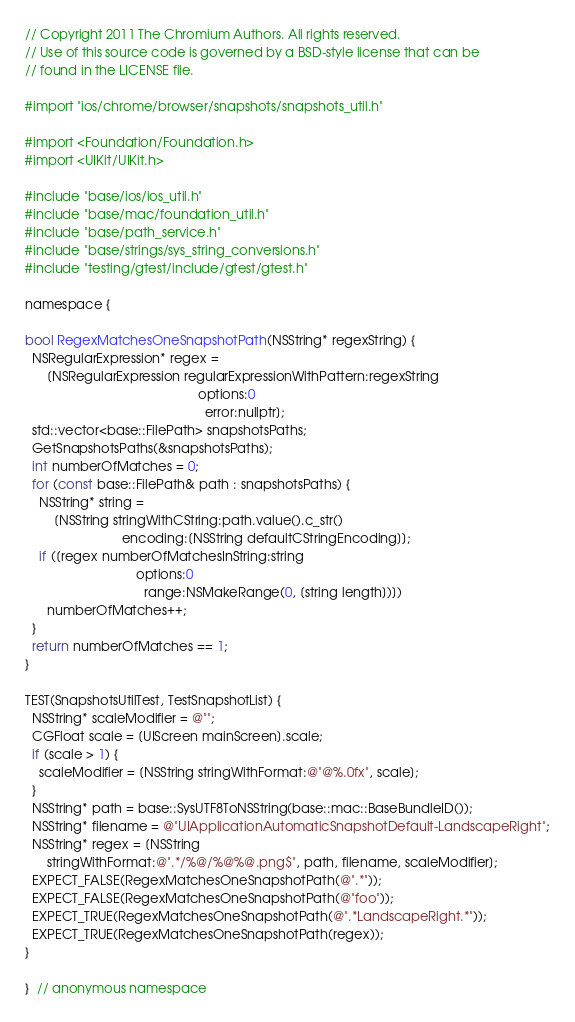Convert code to text. <code><loc_0><loc_0><loc_500><loc_500><_ObjectiveC_>// Copyright 2011 The Chromium Authors. All rights reserved.
// Use of this source code is governed by a BSD-style license that can be
// found in the LICENSE file.

#import "ios/chrome/browser/snapshots/snapshots_util.h"

#import <Foundation/Foundation.h>
#import <UIKit/UIKit.h>

#include "base/ios/ios_util.h"
#include "base/mac/foundation_util.h"
#include "base/path_service.h"
#include "base/strings/sys_string_conversions.h"
#include "testing/gtest/include/gtest/gtest.h"

namespace {

bool RegexMatchesOneSnapshotPath(NSString* regexString) {
  NSRegularExpression* regex =
      [NSRegularExpression regularExpressionWithPattern:regexString
                                                options:0
                                                  error:nullptr];
  std::vector<base::FilePath> snapshotsPaths;
  GetSnapshotsPaths(&snapshotsPaths);
  int numberOfMatches = 0;
  for (const base::FilePath& path : snapshotsPaths) {
    NSString* string =
        [NSString stringWithCString:path.value().c_str()
                           encoding:[NSString defaultCStringEncoding]];
    if ([regex numberOfMatchesInString:string
                               options:0
                                 range:NSMakeRange(0, [string length])])
      numberOfMatches++;
  }
  return numberOfMatches == 1;
}

TEST(SnapshotsUtilTest, TestSnapshotList) {
  NSString* scaleModifier = @"";
  CGFloat scale = [UIScreen mainScreen].scale;
  if (scale > 1) {
    scaleModifier = [NSString stringWithFormat:@"@%.0fx", scale];
  }
  NSString* path = base::SysUTF8ToNSString(base::mac::BaseBundleID());
  NSString* filename = @"UIApplicationAutomaticSnapshotDefault-LandscapeRight";
  NSString* regex = [NSString
      stringWithFormat:@".*/%@/%@%@.png$", path, filename, scaleModifier];
  EXPECT_FALSE(RegexMatchesOneSnapshotPath(@".*"));
  EXPECT_FALSE(RegexMatchesOneSnapshotPath(@"foo"));
  EXPECT_TRUE(RegexMatchesOneSnapshotPath(@".*LandscapeRight.*"));
  EXPECT_TRUE(RegexMatchesOneSnapshotPath(regex));
}

}  // anonymous namespace
</code> 